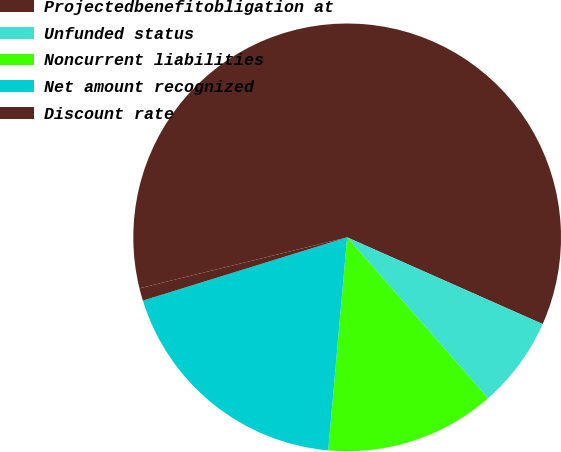Convert chart to OTSL. <chart><loc_0><loc_0><loc_500><loc_500><pie_chart><fcel>Projectedbenefitobligation at<fcel>Unfunded status<fcel>Noncurrent liabilities<fcel>Net amount recognized<fcel>Discount rate<nl><fcel>60.47%<fcel>6.91%<fcel>12.86%<fcel>18.81%<fcel>0.95%<nl></chart> 